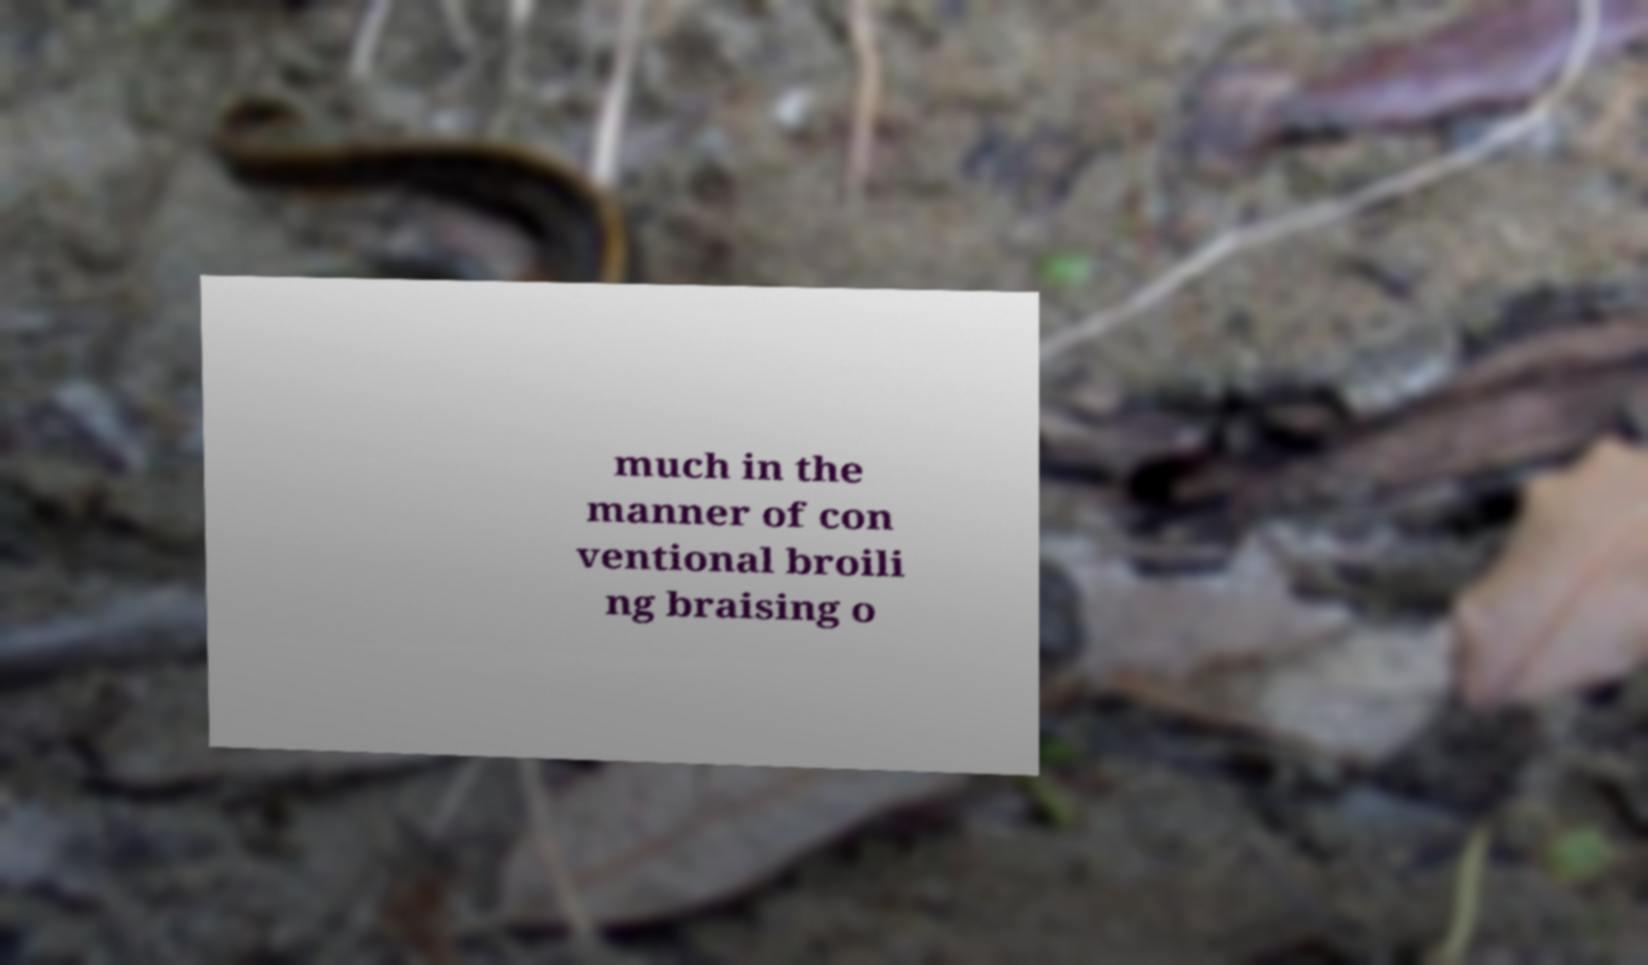There's text embedded in this image that I need extracted. Can you transcribe it verbatim? much in the manner of con ventional broili ng braising o 